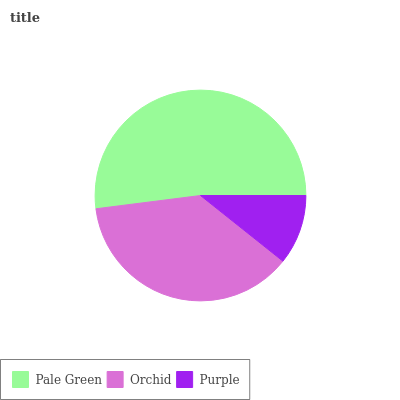Is Purple the minimum?
Answer yes or no. Yes. Is Pale Green the maximum?
Answer yes or no. Yes. Is Orchid the minimum?
Answer yes or no. No. Is Orchid the maximum?
Answer yes or no. No. Is Pale Green greater than Orchid?
Answer yes or no. Yes. Is Orchid less than Pale Green?
Answer yes or no. Yes. Is Orchid greater than Pale Green?
Answer yes or no. No. Is Pale Green less than Orchid?
Answer yes or no. No. Is Orchid the high median?
Answer yes or no. Yes. Is Orchid the low median?
Answer yes or no. Yes. Is Purple the high median?
Answer yes or no. No. Is Purple the low median?
Answer yes or no. No. 